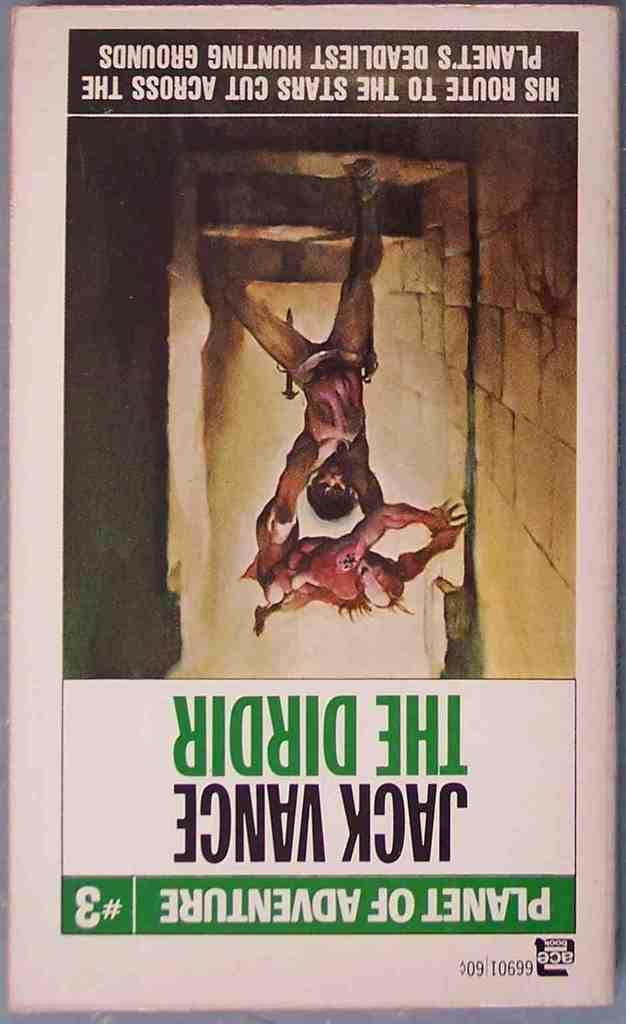<image>
Describe the image concisely. The book shown in the photot is from the series Planet of Adveture. 